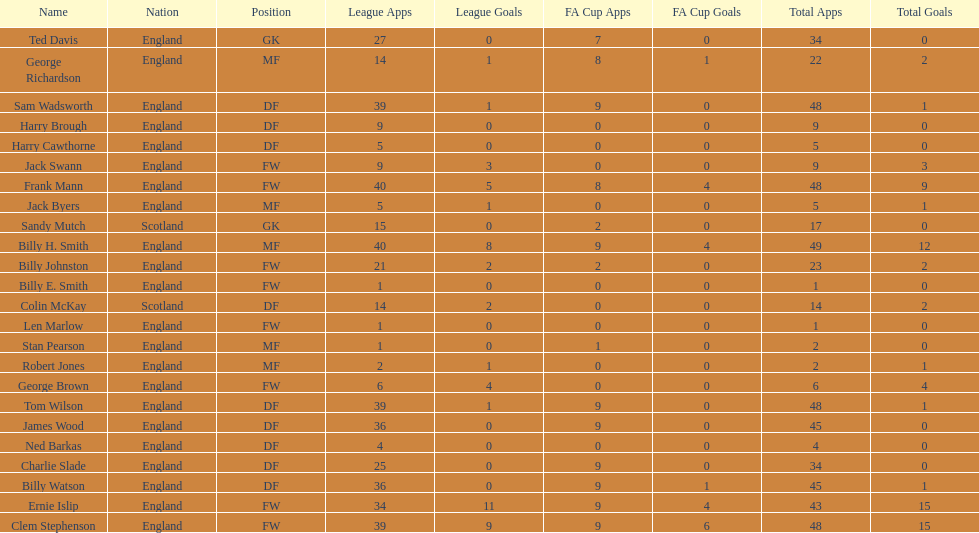Can you parse all the data within this table? {'header': ['Name', 'Nation', 'Position', 'League Apps', 'League Goals', 'FA Cup Apps', 'FA Cup Goals', 'Total Apps', 'Total Goals'], 'rows': [['Ted Davis', 'England', 'GK', '27', '0', '7', '0', '34', '0'], ['George Richardson', 'England', 'MF', '14', '1', '8', '1', '22', '2'], ['Sam Wadsworth', 'England', 'DF', '39', '1', '9', '0', '48', '1'], ['Harry Brough', 'England', 'DF', '9', '0', '0', '0', '9', '0'], ['Harry Cawthorne', 'England', 'DF', '5', '0', '0', '0', '5', '0'], ['Jack Swann', 'England', 'FW', '9', '3', '0', '0', '9', '3'], ['Frank Mann', 'England', 'FW', '40', '5', '8', '4', '48', '9'], ['Jack Byers', 'England', 'MF', '5', '1', '0', '0', '5', '1'], ['Sandy Mutch', 'Scotland', 'GK', '15', '0', '2', '0', '17', '0'], ['Billy H. Smith', 'England', 'MF', '40', '8', '9', '4', '49', '12'], ['Billy Johnston', 'England', 'FW', '21', '2', '2', '0', '23', '2'], ['Billy E. Smith', 'England', 'FW', '1', '0', '0', '0', '1', '0'], ['Colin McKay', 'Scotland', 'DF', '14', '2', '0', '0', '14', '2'], ['Len Marlow', 'England', 'FW', '1', '0', '0', '0', '1', '0'], ['Stan Pearson', 'England', 'MF', '1', '0', '1', '0', '2', '0'], ['Robert Jones', 'England', 'MF', '2', '1', '0', '0', '2', '1'], ['George Brown', 'England', 'FW', '6', '4', '0', '0', '6', '4'], ['Tom Wilson', 'England', 'DF', '39', '1', '9', '0', '48', '1'], ['James Wood', 'England', 'DF', '36', '0', '9', '0', '45', '0'], ['Ned Barkas', 'England', 'DF', '4', '0', '0', '0', '4', '0'], ['Charlie Slade', 'England', 'DF', '25', '0', '9', '0', '34', '0'], ['Billy Watson', 'England', 'DF', '36', '0', '9', '1', '45', '1'], ['Ernie Islip', 'England', 'FW', '34', '11', '9', '4', '43', '15'], ['Clem Stephenson', 'England', 'FW', '39', '9', '9', '6', '48', '15']]} How many players are fws? 8. 